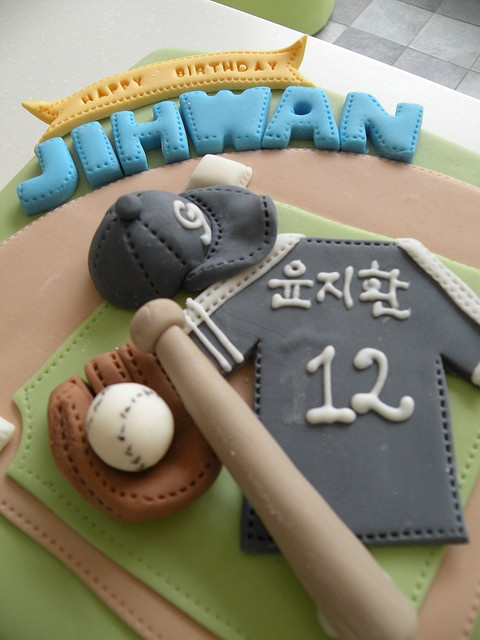Describe the objects in this image and their specific colors. I can see cake in darkgray, gray, black, and maroon tones, baseball bat in darkgray, tan, and gray tones, baseball glove in darkgray, maroon, black, and gray tones, and sports ball in darkgray, ivory, gray, and tan tones in this image. 